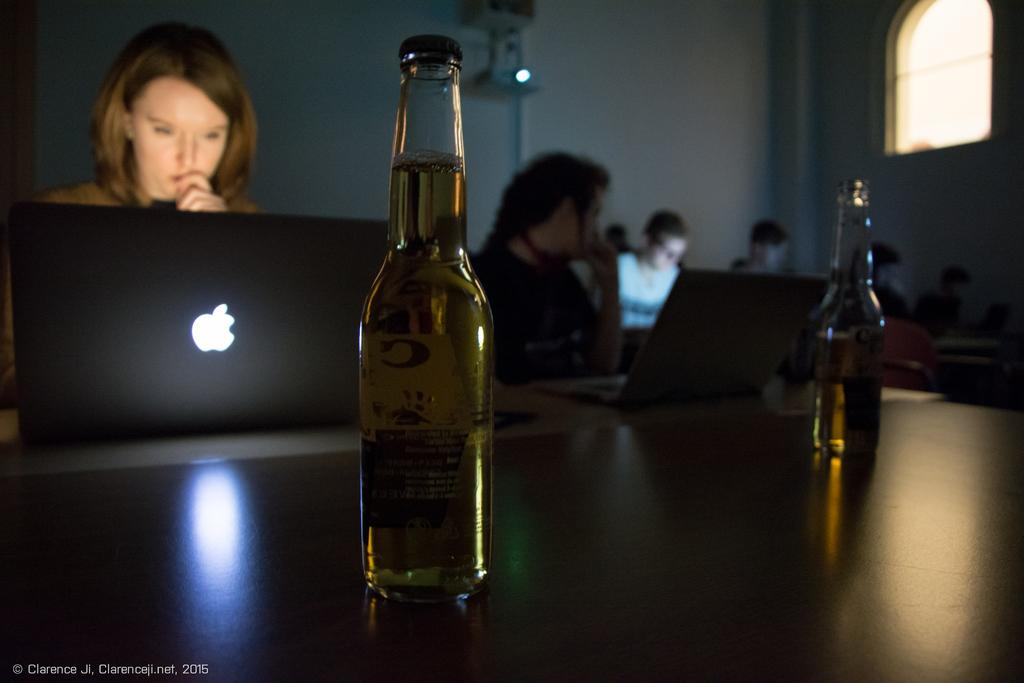What object is placed on the table in the image? There is a bottle placed on a table in the image. What activity are the persons in the background of the image engaged in? The persons in the background of the image are using a laptop. What type of rose can be seen hanging from the curtain in the image? There is no rose or curtain present in the image. 